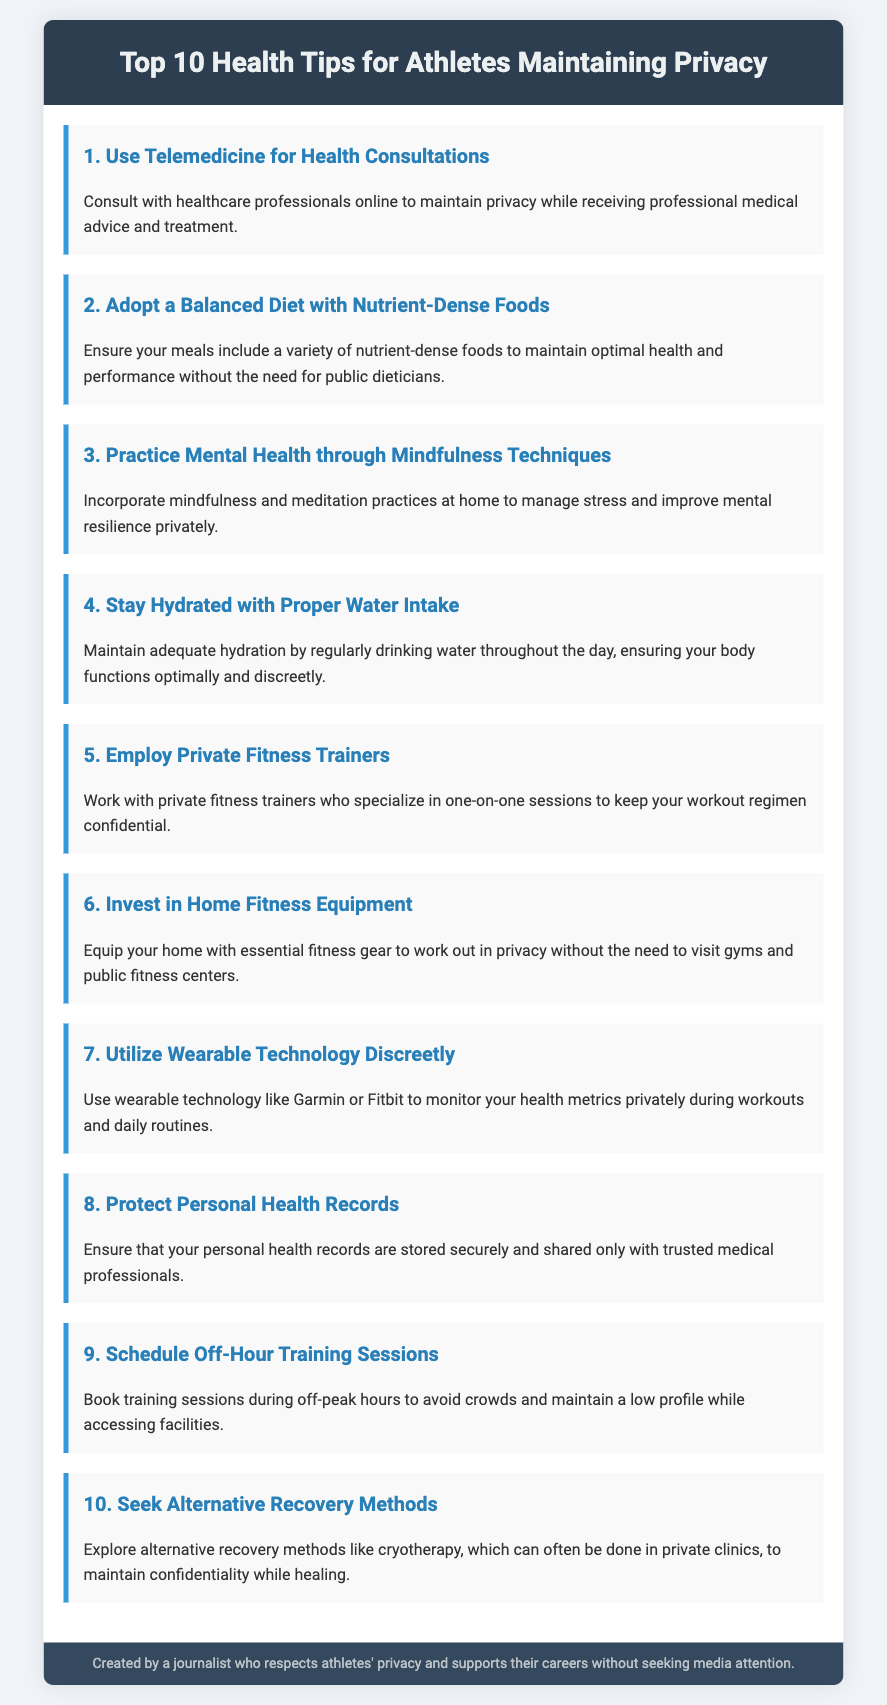what is the first health tip for athletes? The first health tip listed in the document is about using telemedicine for health consultations.
Answer: Use Telemedicine for Health Consultations how many tips are provided in the document? The document contains a total of ten health tips for athletes.
Answer: 10 what technique is suggested for managing mental health? The document suggests incorporating mindfulness and meditation practices for mental health management.
Answer: Mindfulness Techniques why should athletes consider private fitness trainers? Athletes should consider private fitness trainers to keep their workout regimen confidential.
Answer: To keep workouts confidential what is the purpose of using wearable technology? The purpose of using wearable technology is to monitor health metrics privately during workouts and daily routines.
Answer: Monitor health metrics privately which training schedule is recommended to maintain a low profile? The document recommends scheduling off-hour training sessions to avoid crowds and maintain privacy.
Answer: Off-Hour Training Sessions what method is suggested for recovery in private? The document suggests exploring alternative recovery methods like cryotherapy, often done in private clinics.
Answer: Cryotherapy how should personal health records be managed? Personal health records should be stored securely and shared only with trusted medical professionals.
Answer: Stored securely what color is the header background? The header background color of the document is a dark blue color.
Answer: Dark blue what is the purpose of this document? The purpose of the document is to provide health tips for athletes while respecting their privacy.
Answer: Provide health tips while respecting privacy 